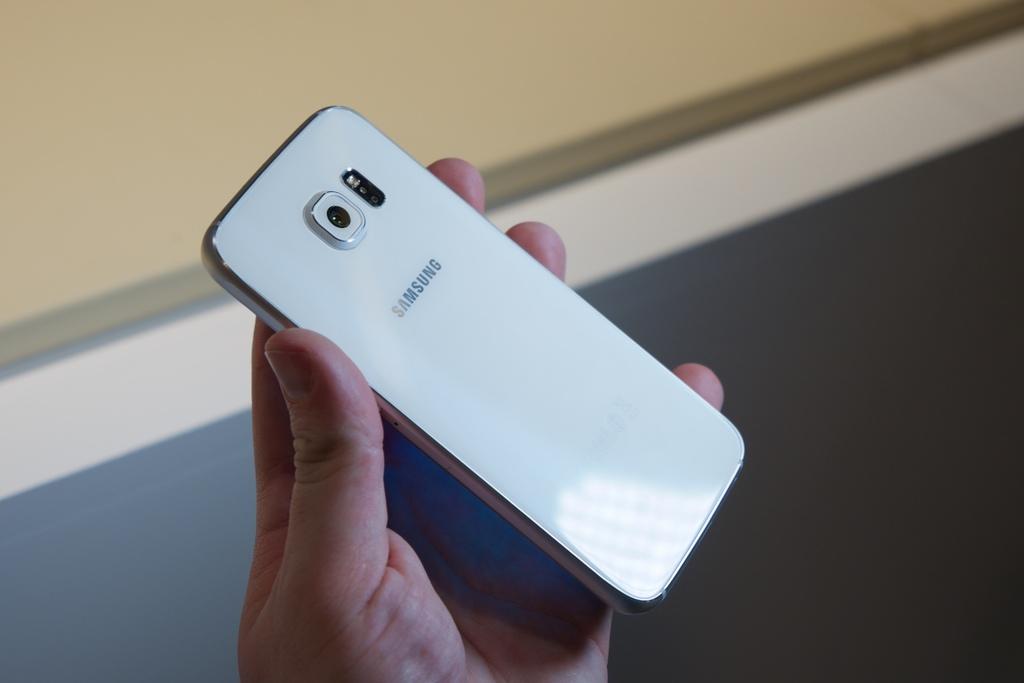What brand is this phone?
Keep it short and to the point. Samsung. 